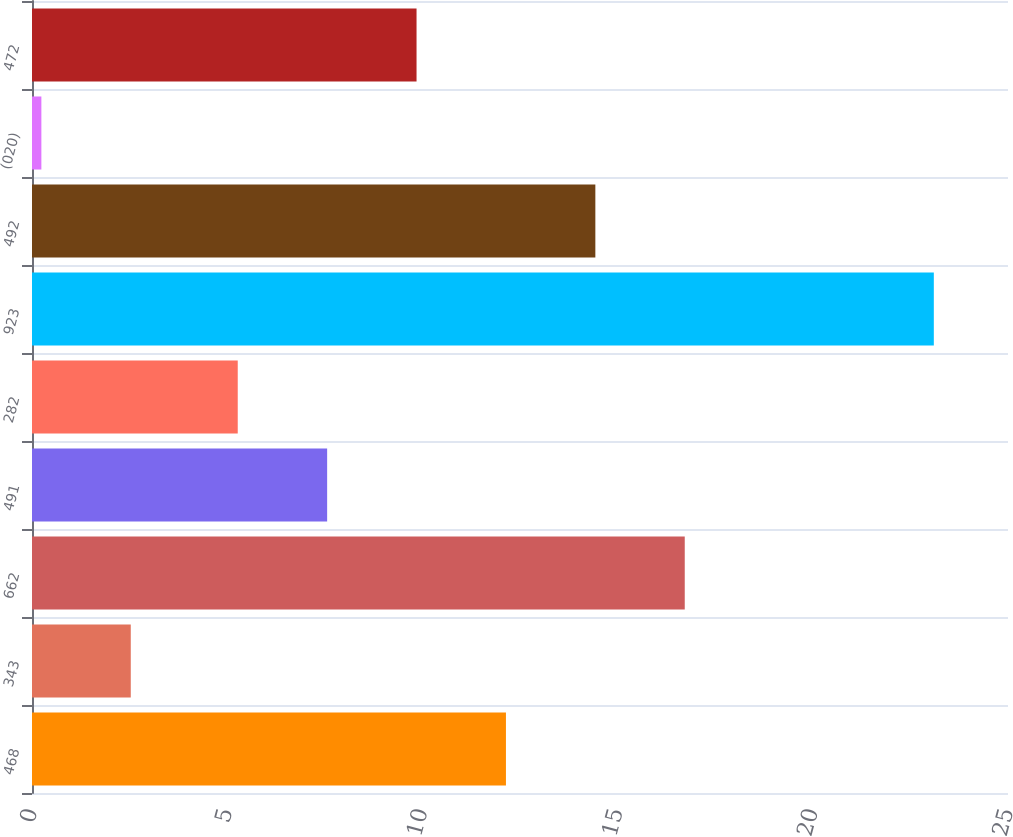Convert chart to OTSL. <chart><loc_0><loc_0><loc_500><loc_500><bar_chart><fcel>468<fcel>343<fcel>662<fcel>491<fcel>282<fcel>923<fcel>492<fcel>(020)<fcel>472<nl><fcel>12.14<fcel>2.53<fcel>16.72<fcel>7.56<fcel>5.27<fcel>23.1<fcel>14.43<fcel>0.24<fcel>9.85<nl></chart> 